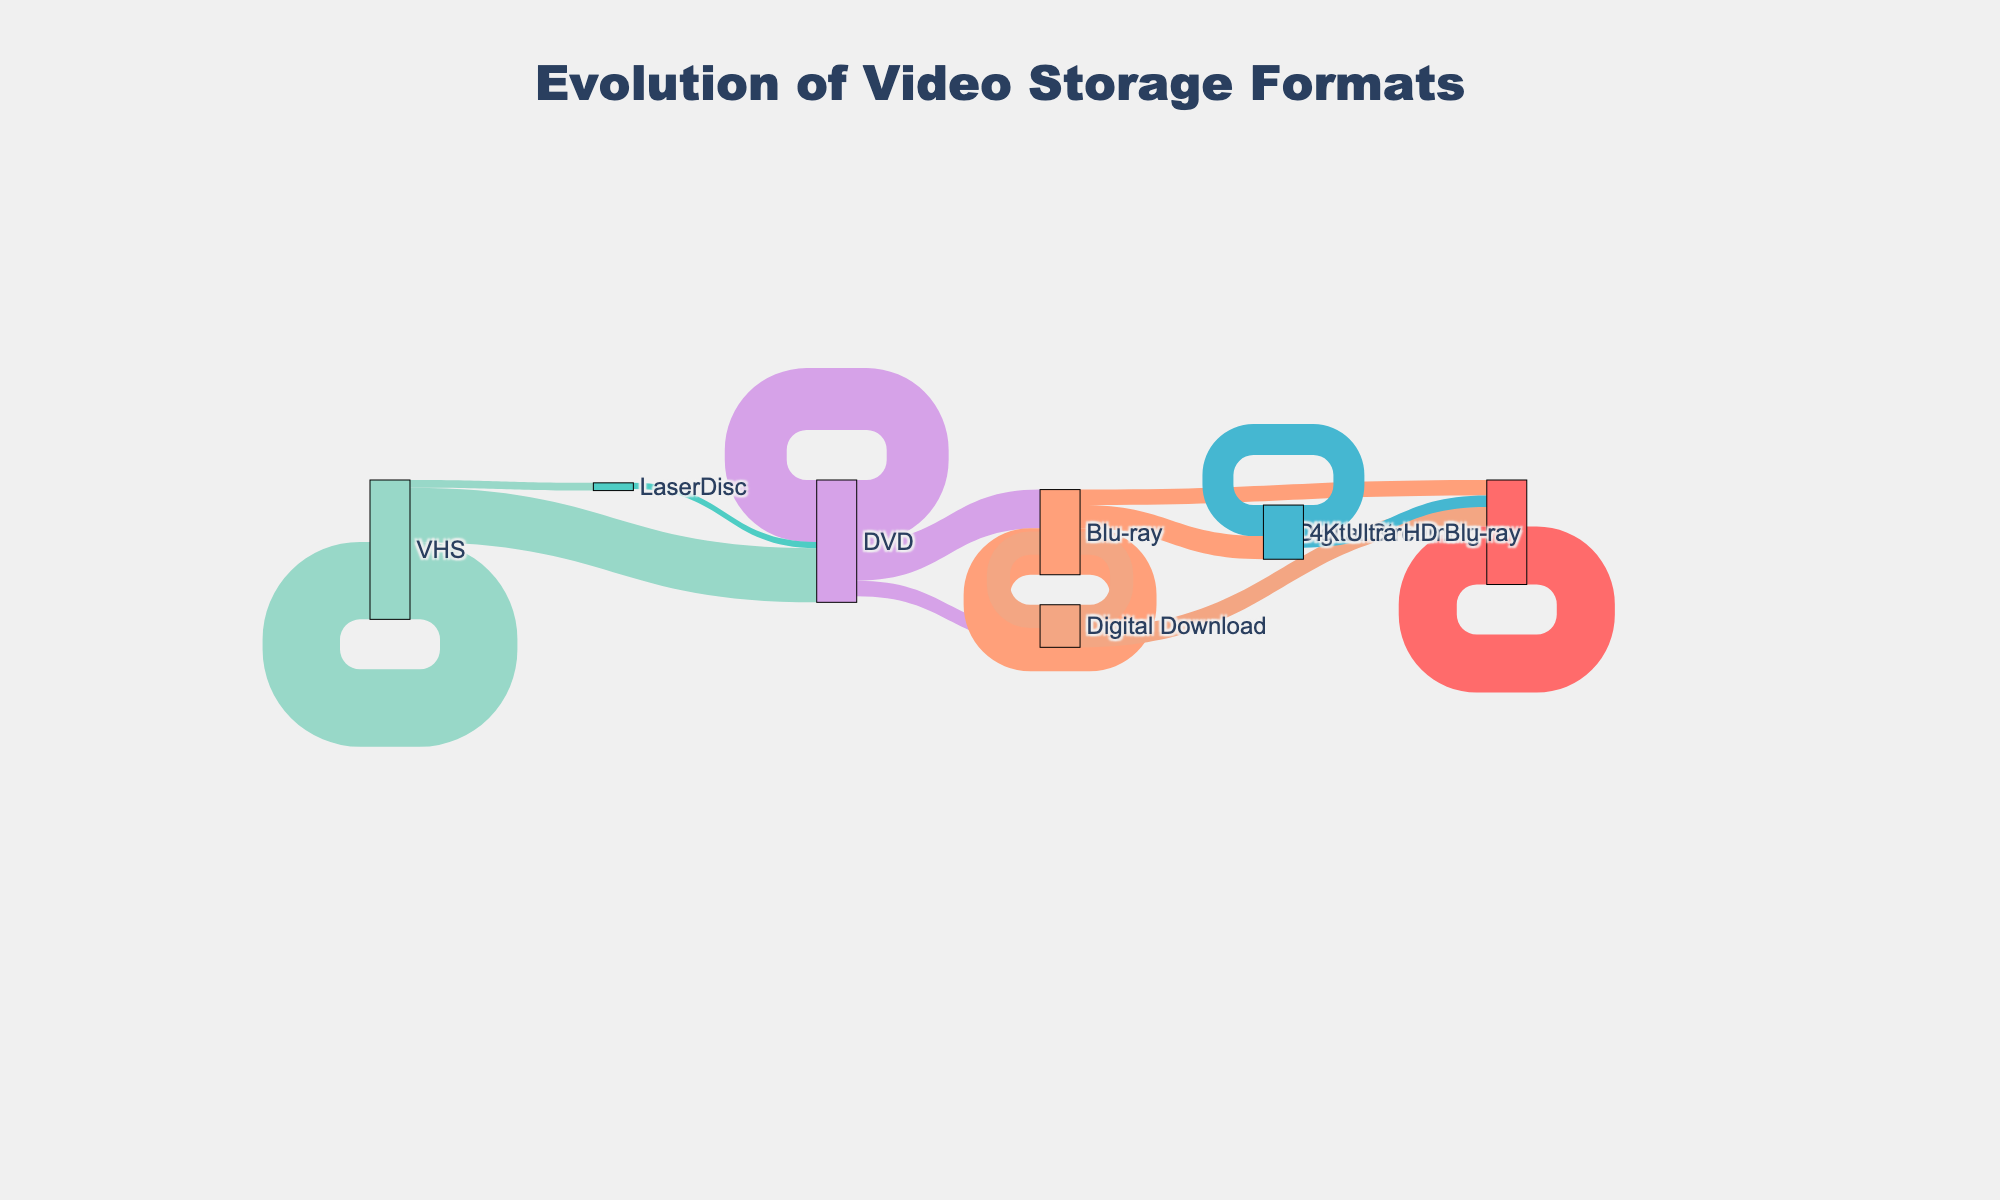What is the title of the Sankey diagram? The title is typically located at the top of the diagram and gives an overview of the visualization. Here, it states "Evolution of Video Storage Formats".
Answer: Evolution of Video Storage Formats How many different video storage formats are listed in the diagram? By inspecting the labels of the nodes in the diagram, you can count how many unique formats are displayed.
Answer: 9 What is the original format with the highest initial market share? To find the original format with the highest initial market share, look at the values for the "source" nodes that do not have incoming links from other nodes. VHS has a value of 100, which is higher than any other initial formats.
Answer: VHS Which format did DVD transition into the most, and what was the value? To determine this, find the "DVD" source node and inspect the outgoing links. The highest value out of DVD's transitions is to Blu-ray, which has a value of 50.
Answer: Blu-ray, 50 What is the combined market share that transitioned from VHS to new formats excluding itself? Adding the values of transitions from VHS to all formats except VHS: VHS to DVD (70) + VHS to LaserDisc (10) gives a total of 80.
Answer: 80 How does the market share of Digital Streaming compare to 4K Ultra HD Blu-ray in their category? Inspect the values within the target nodes for "Digital Streaming" and "4K Ultra HD Blu-ray". Digital Streaming has input values of 25 from Digital Download, and 20 from Blu-ray, totaling 45. 4K Ultra HD Blu-ray has a total of 30 from Blu-ray. Digital Streaming (45) is higher than 4K Ultra HD Blu-ray (30) within this transition category.
Answer: Digital Streaming is higher Which format has the most longevity in terms of sustaining its market share within itself? Look for formats with high values that loop back to themselves. "Digital Streaming" maintains a high internal value of 75, the highest self-sustaining value compared to others.
Answer: Digital Streaming Does Blu-ray contribute more to Digital Streaming or 4K Ultra HD Blu-ray? Compare the outgoing values from Blu-ray to both targets. Blu-ray to Digital Streaming is 20 and Blu-ray to 4K Ultra HD Blu-ray is 30. Hence, Blu-ray contributes more to 4K Ultra HD Blu-ray.
Answer: 4K Ultra HD Blu-ray From which format did Digital Download receive the most market share? Inspect the inflow for the "Digital Download" target node. The only contributing source is DVD with a value of 20.
Answer: DVD 